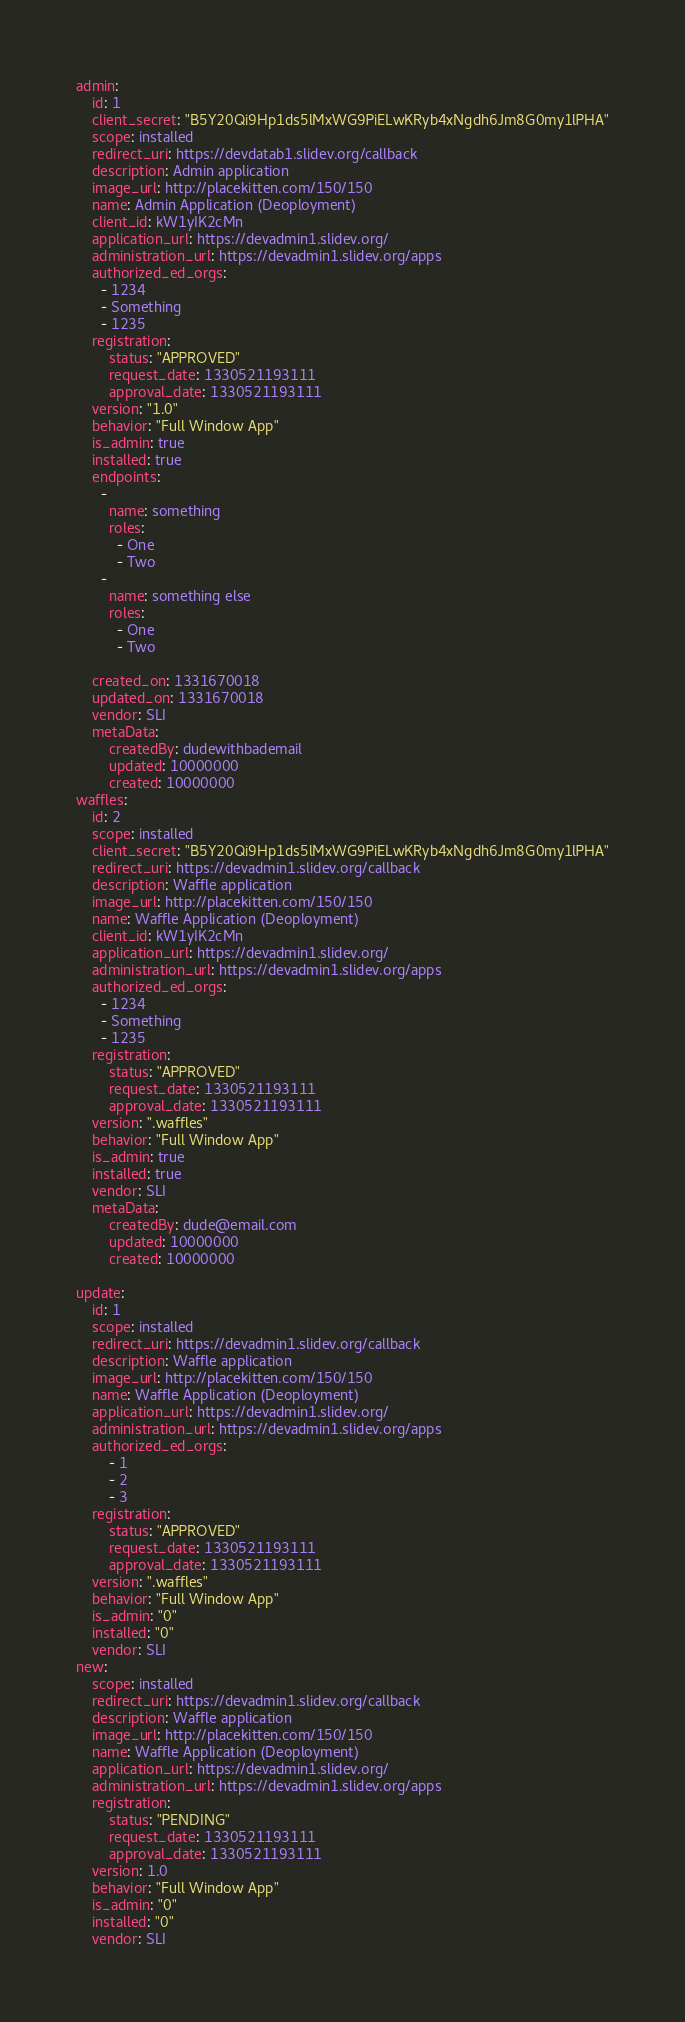<code> <loc_0><loc_0><loc_500><loc_500><_YAML_>admin:
    id: 1
    client_secret: "B5Y20Qi9Hp1ds5lMxWG9PiELwKRyb4xNgdh6Jm8G0my1lPHA"
    scope: installed
    redirect_uri: https://devdatab1.slidev.org/callback
    description: Admin application
    image_url: http://placekitten.com/150/150
    name: Admin Application (Deoployment)
    client_id: kW1yIK2cMn
    application_url: https://devadmin1.slidev.org/
    administration_url: https://devadmin1.slidev.org/apps
    authorized_ed_orgs:
      - 1234
      - Something
      - 1235
    registration:
        status: "APPROVED"
        request_date: 1330521193111
        approval_date: 1330521193111
    version: "1.0"
    behavior: "Full Window App"
    is_admin: true
    installed: true
    endpoints:
      -
        name: something
        roles:
          - One
          - Two
      -
        name: something else
        roles:
          - One
          - Two

    created_on: 1331670018
    updated_on: 1331670018
    vendor: SLI
    metaData:
        createdBy: dudewithbademail
        updated: 10000000
        created: 10000000
waffles:
    id: 2
    scope: installed
    client_secret: "B5Y20Qi9Hp1ds5lMxWG9PiELwKRyb4xNgdh6Jm8G0my1lPHA"
    redirect_uri: https://devadmin1.slidev.org/callback
    description: Waffle application
    image_url: http://placekitten.com/150/150
    name: Waffle Application (Deoployment)
    client_id: kW1yIK2cMn
    application_url: https://devadmin1.slidev.org/
    administration_url: https://devadmin1.slidev.org/apps
    authorized_ed_orgs:
      - 1234
      - Something
      - 1235
    registration:
        status: "APPROVED"
        request_date: 1330521193111
        approval_date: 1330521193111
    version: ".waffles"
    behavior: "Full Window App"
    is_admin: true
    installed: true
    vendor: SLI
    metaData:
        createdBy: dude@email.com
        updated: 10000000
        created: 10000000
        
update:
    id: 1
    scope: installed
    redirect_uri: https://devadmin1.slidev.org/callback
    description: Waffle application
    image_url: http://placekitten.com/150/150
    name: Waffle Application (Deoployment)
    application_url: https://devadmin1.slidev.org/
    administration_url: https://devadmin1.slidev.org/apps
    authorized_ed_orgs:
        - 1
        - 2
        - 3
    registration:
        status: "APPROVED"
        request_date: 1330521193111
        approval_date: 1330521193111
    version: ".waffles"
    behavior: "Full Window App"
    is_admin: "0"
    installed: "0"
    vendor: SLI
new:
    scope: installed
    redirect_uri: https://devadmin1.slidev.org/callback
    description: Waffle application
    image_url: http://placekitten.com/150/150
    name: Waffle Application (Deoployment)
    application_url: https://devadmin1.slidev.org/
    administration_url: https://devadmin1.slidev.org/apps
    registration:
        status: "PENDING"
        request_date: 1330521193111
        approval_date: 1330521193111
    version: 1.0
    behavior: "Full Window App"
    is_admin: "0"
    installed: "0"
    vendor: SLI

</code> 